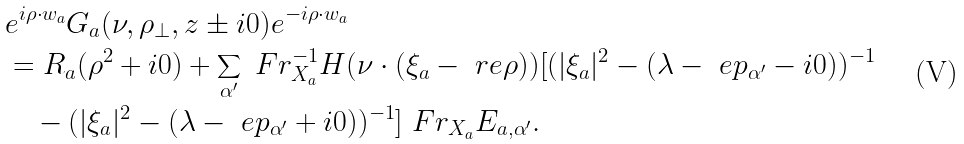Convert formula to latex. <formula><loc_0><loc_0><loc_500><loc_500>& e ^ { i \rho \cdot w _ { a } } G _ { a } ( \nu , \rho _ { \perp } , z \pm i 0 ) e ^ { - i \rho \cdot w _ { a } } \\ & = R _ { a } ( \rho ^ { 2 } + i 0 ) + \sum _ { \alpha ^ { \prime } } \ F r ^ { - 1 } _ { X _ { a } } H ( \nu \cdot ( \xi _ { a } - \ r e \rho ) ) [ ( | \xi _ { a } | ^ { 2 } - ( \lambda - \ e p _ { \alpha ^ { \prime } } - i 0 ) ) ^ { - 1 } \\ & \quad - ( | \xi _ { a } | ^ { 2 } - ( \lambda - \ e p _ { \alpha ^ { \prime } } + i 0 ) ) ^ { - 1 } ] \ F r _ { X _ { a } } E _ { a , \alpha ^ { \prime } } .</formula> 